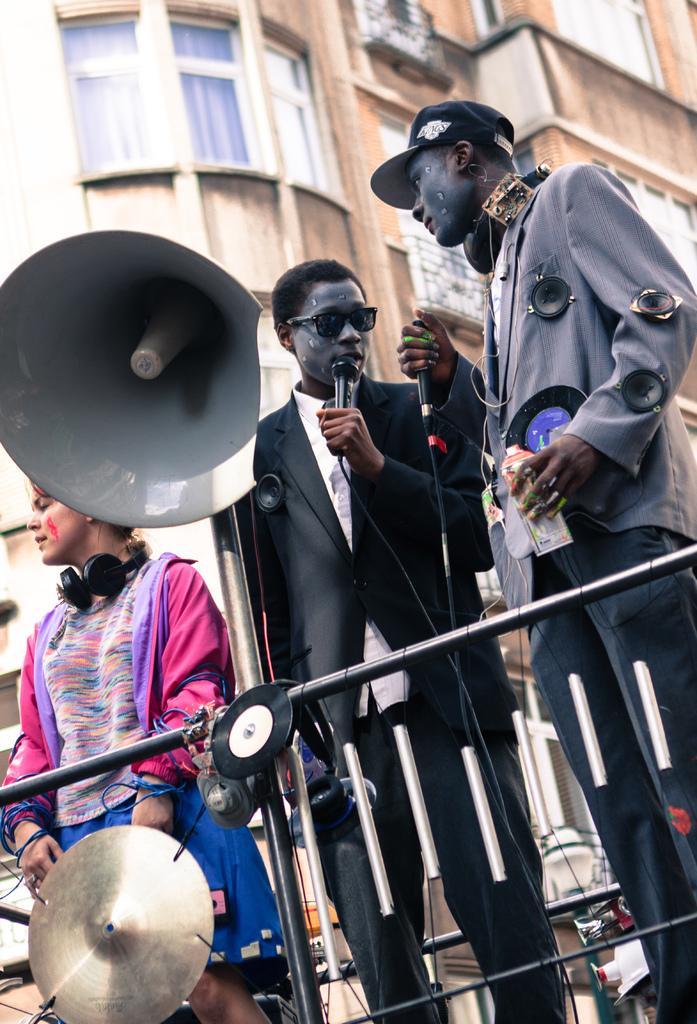In one or two sentences, can you explain what this image depicts? In this image there are two persons holding the mike. Beside them there is another person wearing a headset. In front of them there is a metal fence. Behind them there is a speaker. In the background of the image there are buildings. 